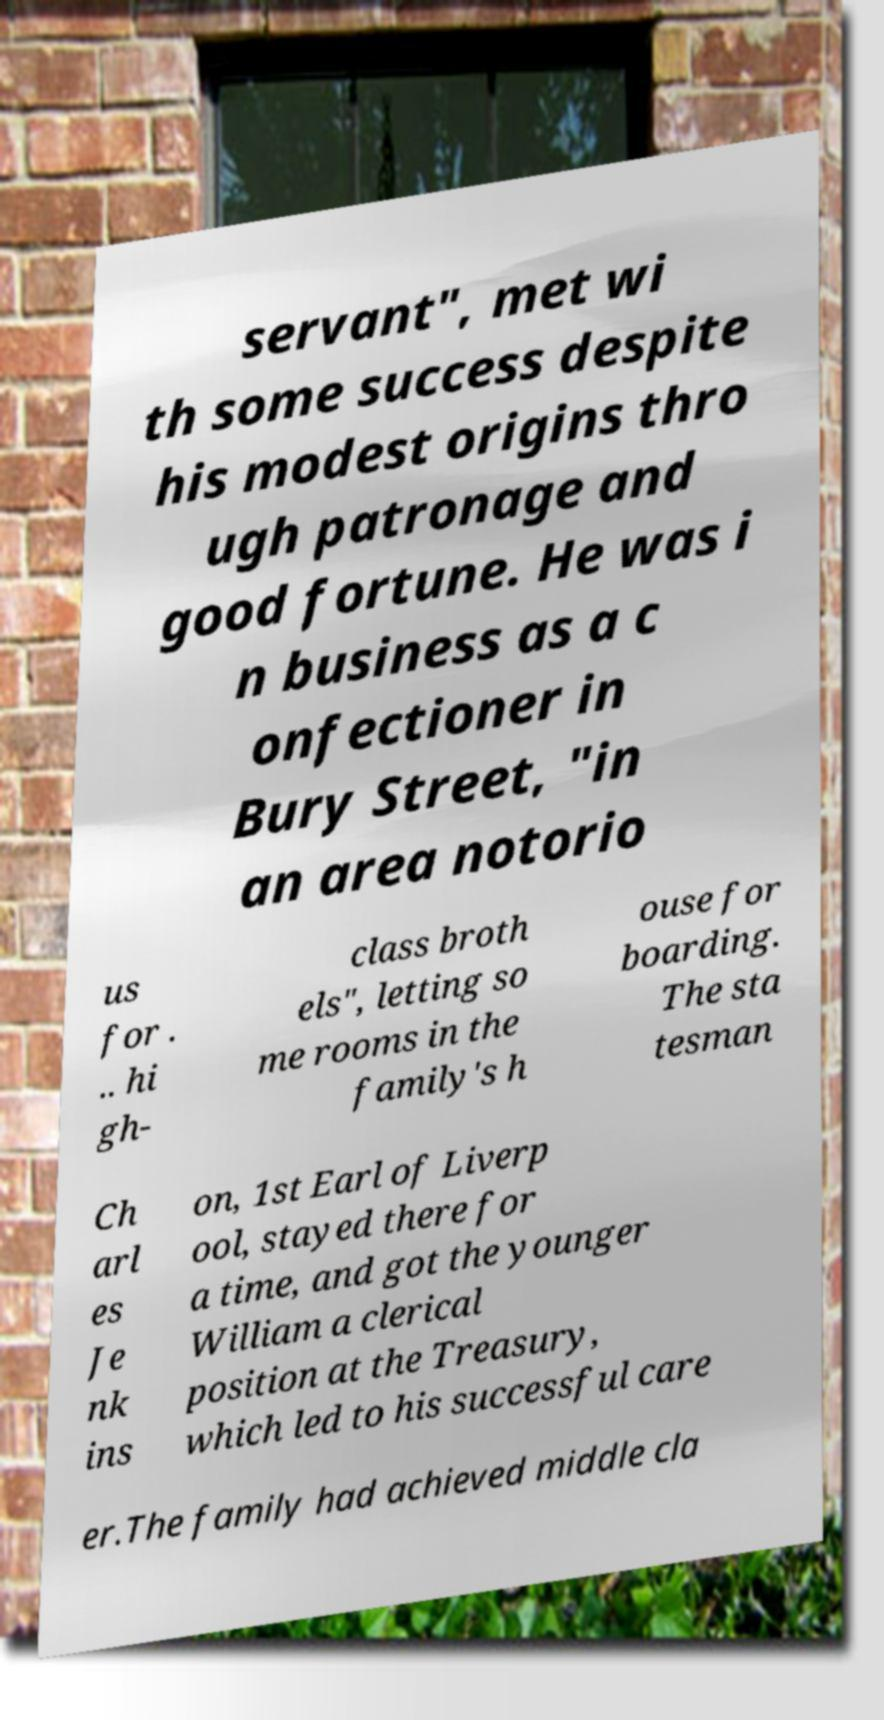Can you accurately transcribe the text from the provided image for me? servant", met wi th some success despite his modest origins thro ugh patronage and good fortune. He was i n business as a c onfectioner in Bury Street, "in an area notorio us for . .. hi gh- class broth els", letting so me rooms in the family's h ouse for boarding. The sta tesman Ch arl es Je nk ins on, 1st Earl of Liverp ool, stayed there for a time, and got the younger William a clerical position at the Treasury, which led to his successful care er.The family had achieved middle cla 